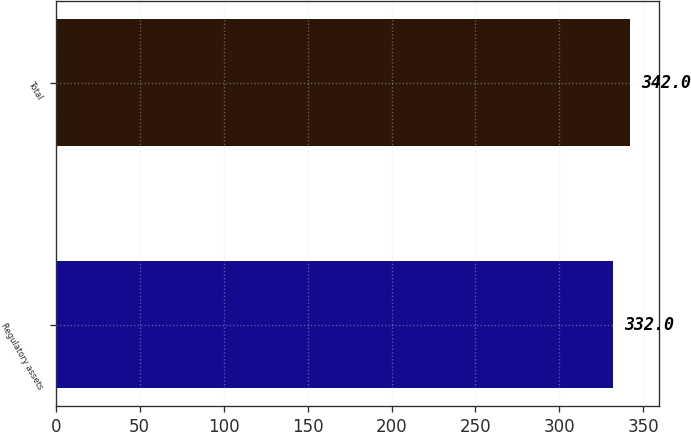Convert chart to OTSL. <chart><loc_0><loc_0><loc_500><loc_500><bar_chart><fcel>Regulatory assets<fcel>Total<nl><fcel>332<fcel>342<nl></chart> 